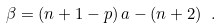Convert formula to latex. <formula><loc_0><loc_0><loc_500><loc_500>\beta = ( n + 1 - p ) \, a - ( n + 2 ) \ .</formula> 